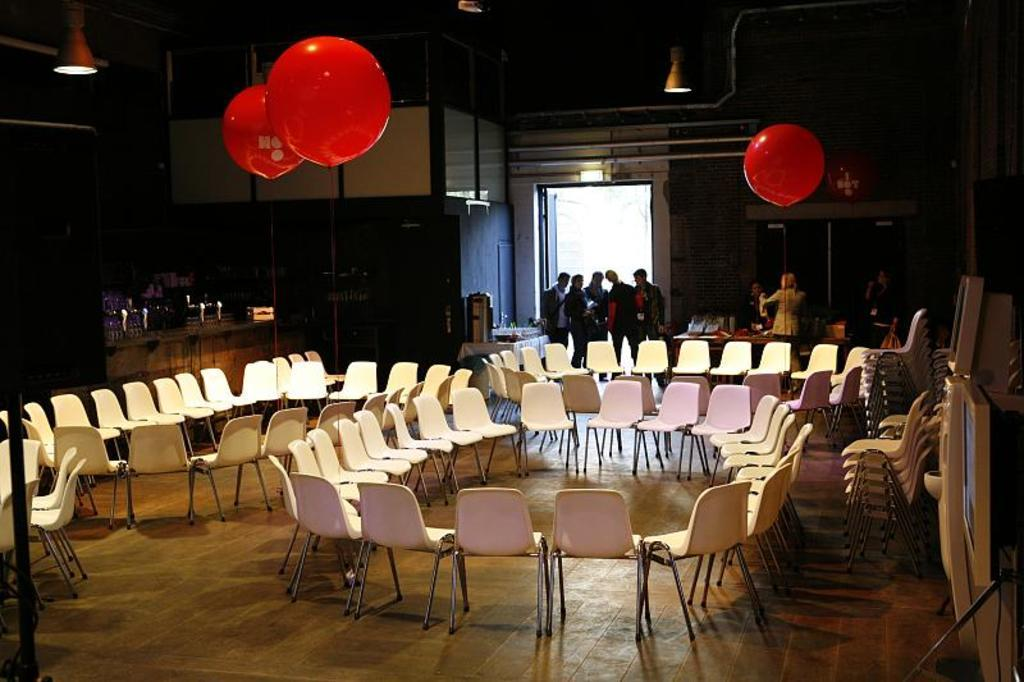How are the chairs arranged in the image? The chairs are placed in a circular pattern. What can be seen in the background of the image? In the background, there are people at the entry door, balloons, lights, a wall, doors, and poles. Can you describe the arrangement of the chairs in relation to the background? The chairs are arranged in a circular pattern, with the background elements visible behind them. What type of arm is holding the kitten in the image? There is no kitten or arm present in the image. 